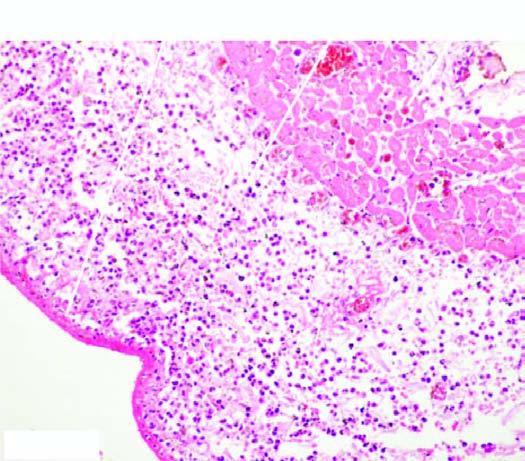does the space between the layers of the pericardium contain numerous inflammatory cells, chiefly pmns?
Answer the question using a single word or phrase. Yes 